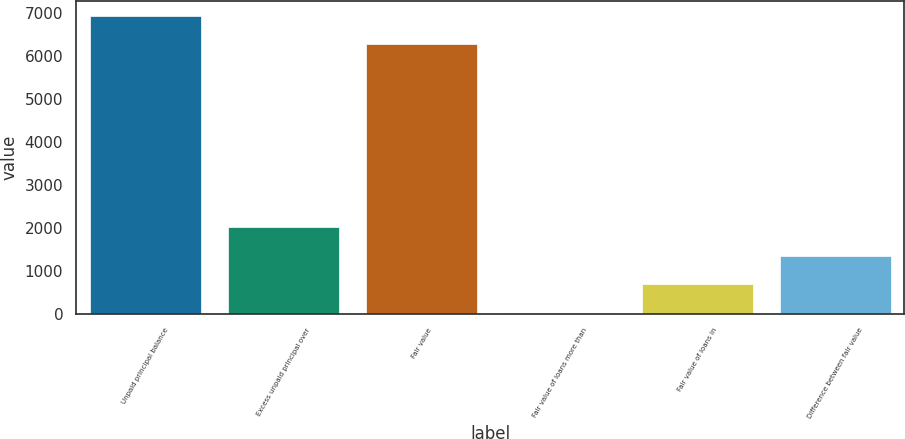<chart> <loc_0><loc_0><loc_500><loc_500><bar_chart><fcel>Unpaid principal balance<fcel>Excess unpaid principal over<fcel>Fair value<fcel>Fair value of loans more than<fcel>Fair value of loans in<fcel>Difference between fair value<nl><fcel>6928.1<fcel>2007.3<fcel>6267<fcel>24<fcel>685.1<fcel>1346.2<nl></chart> 